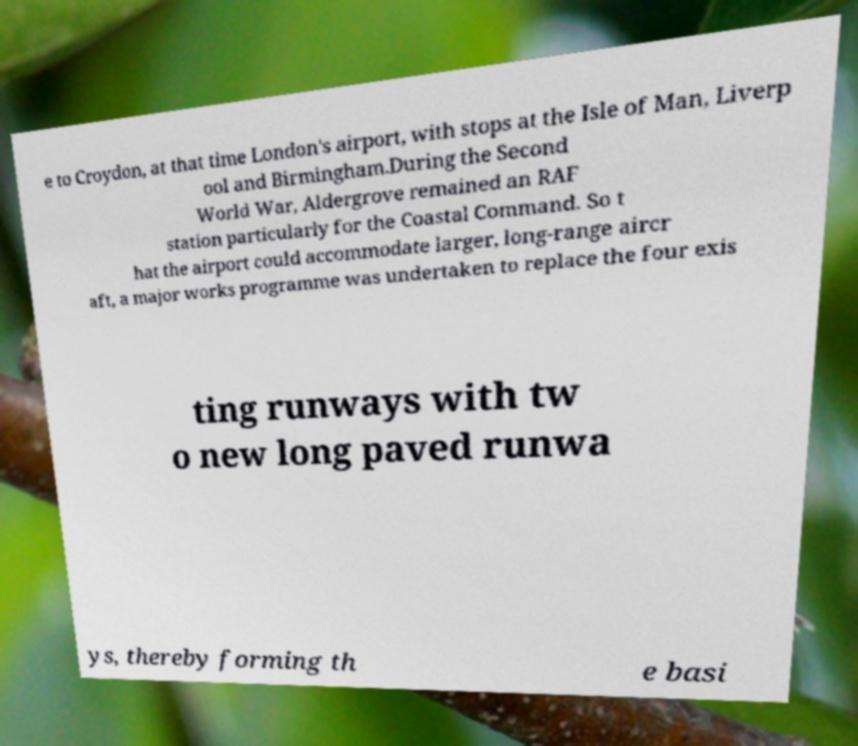Could you extract and type out the text from this image? e to Croydon, at that time London's airport, with stops at the Isle of Man, Liverp ool and Birmingham.During the Second World War, Aldergrove remained an RAF station particularly for the Coastal Command. So t hat the airport could accommodate larger, long-range aircr aft, a major works programme was undertaken to replace the four exis ting runways with tw o new long paved runwa ys, thereby forming th e basi 